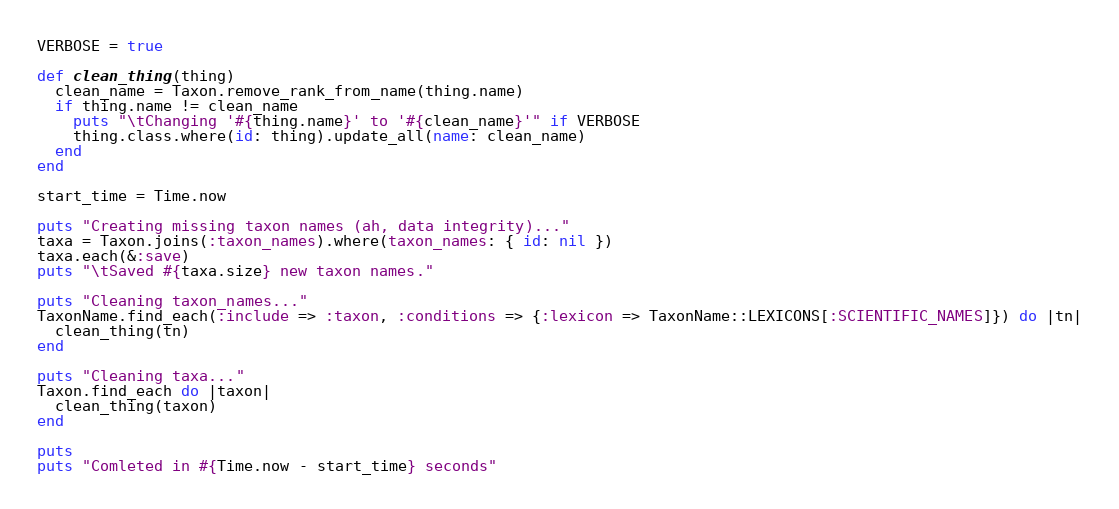Convert code to text. <code><loc_0><loc_0><loc_500><loc_500><_Ruby_>VERBOSE = true

def clean_thing(thing)
  clean_name = Taxon.remove_rank_from_name(thing.name)
  if thing.name != clean_name
    puts "\tChanging '#{thing.name}' to '#{clean_name}'" if VERBOSE
    thing.class.where(id: thing).update_all(name: clean_name)
  end
end

start_time = Time.now

puts "Creating missing taxon names (ah, data integrity)..."
taxa = Taxon.joins(:taxon_names).where(taxon_names: { id: nil })
taxa.each(&:save)
puts "\tSaved #{taxa.size} new taxon names."

puts "Cleaning taxon_names..."
TaxonName.find_each(:include => :taxon, :conditions => {:lexicon => TaxonName::LEXICONS[:SCIENTIFIC_NAMES]}) do |tn|
  clean_thing(tn)
end

puts "Cleaning taxa..."
Taxon.find_each do |taxon|
  clean_thing(taxon)
end

puts
puts "Comleted in #{Time.now - start_time} seconds"</code> 